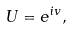<formula> <loc_0><loc_0><loc_500><loc_500>U = e ^ { i v } ,</formula> 